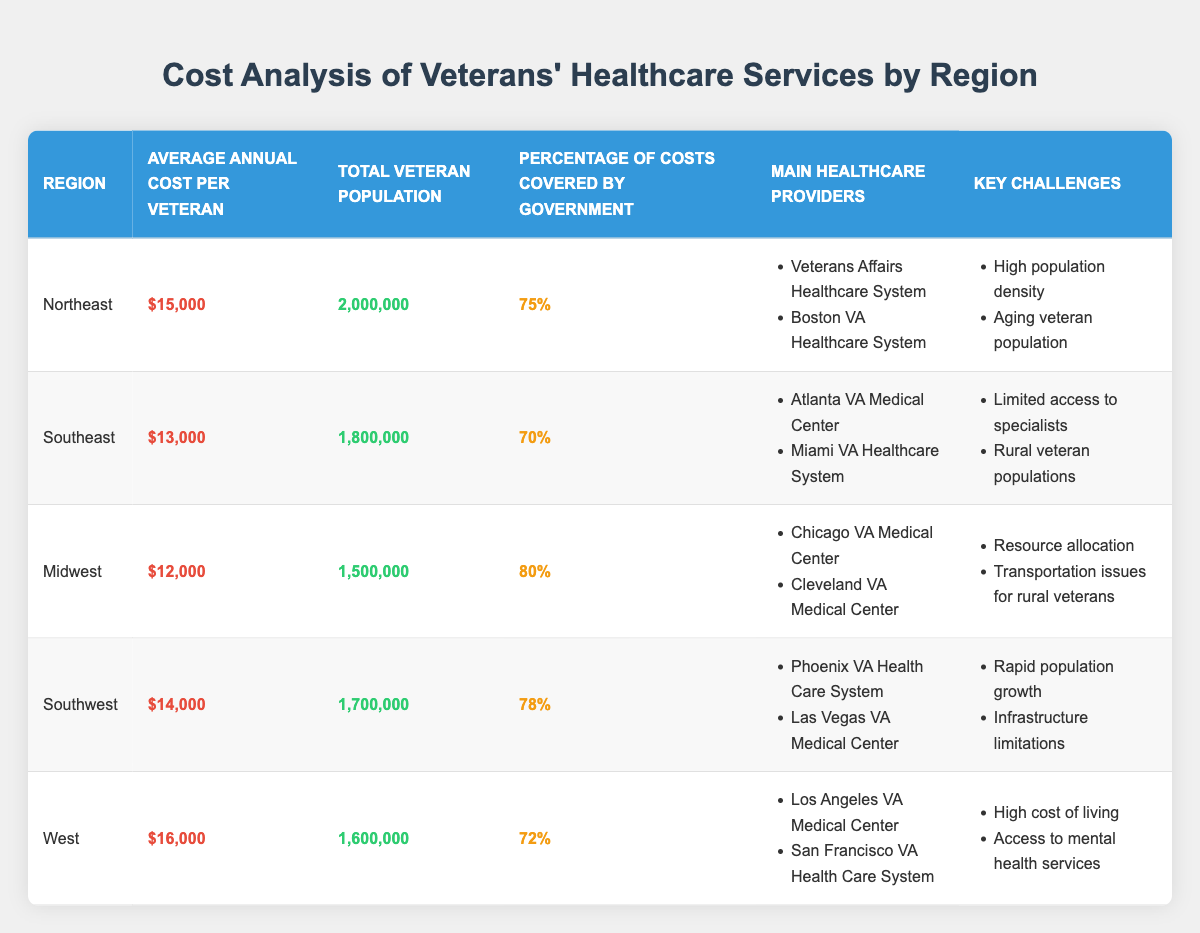What is the average annual cost per veteran in the Northeast region? The table specifies that the average annual cost per veteran in the Northeast region is listed as $15,000.
Answer: $15,000 Which region has the highest percentage of costs covered by the government? Referring to the table, the Midwest region has the highest percentage at 80% when compared to the other regions.
Answer: Midwest What are the key challenges faced by veterans in the Southeast region? In the Southeast region, the challenges specified in the table include limited access to specialists and rural veteran populations.
Answer: Limited access to specialists, rural veteran populations How many veterans are there in the Southwest region compared to the Midwest region? The table indicates that the Southwest region has 1,700,000 veterans, while the Midwest region has 1,500,000 veterans. Thus, the Southwest region has 200,000 more veterans than the Midwest region.
Answer: 200,000 more veterans Is the average annual cost per veteran in the West region greater than in the Southeast region? The average annual cost per veteran in the West region is $16,000, while in the Southeast it is $13,000. Since $16,000 is greater than $13,000, this statement is true.
Answer: Yes What is the combined total veteran population of the Northeast and Midwest regions? The Northeast has a veteran population of 2,000,000 and the Midwest has 1,500,000. Adding these two figures together (2,000,000 + 1,500,000 = 3,500,000) gives the combined veteran population.
Answer: 3,500,000 Does any region have a government coverage percentage below 70%? According to the table, the Southeast (70%) and West (72%) regions both have percentages at or above, but not below, 70%. Therefore, there is no region below 70%.
Answer: No In which region is the average annual cost per veteran closest to the national average of $14,000? Evaluating the average costs listed, the Southwest region is at $14,000, while the others are either higher or lower (Northeast: $15,000; Southeast: $13,000; Midwest: $12,000; West: $16,000). Thus, the Southwest region matches the national average exactly.
Answer: Southwest 